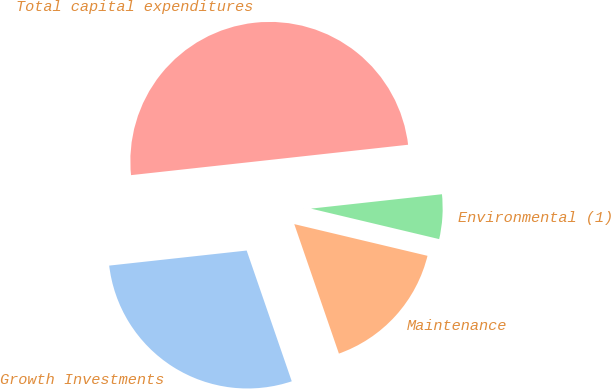Convert chart to OTSL. <chart><loc_0><loc_0><loc_500><loc_500><pie_chart><fcel>Growth Investments<fcel>Maintenance<fcel>Environmental (1)<fcel>Total capital expenditures<nl><fcel>28.55%<fcel>16.0%<fcel>5.46%<fcel>50.0%<nl></chart> 